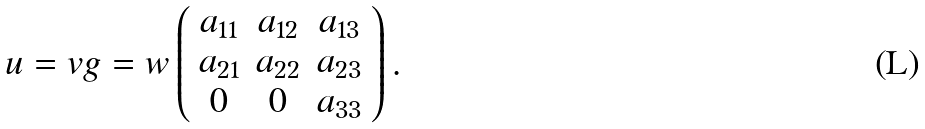Convert formula to latex. <formula><loc_0><loc_0><loc_500><loc_500>u = v g = w \left ( \begin{array} { c c c } a _ { 1 1 } & a _ { 1 2 } & a _ { 1 3 } \\ a _ { 2 1 } & a _ { 2 2 } & a _ { 2 3 } \\ 0 & 0 & a _ { 3 3 } \end{array} \right ) .</formula> 